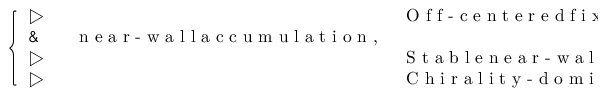<formula> <loc_0><loc_0><loc_500><loc_500>\begin{array} { r } { \left \{ \begin{array} { l l } { \triangleright \, } & { O f f - c e n t e r e d f i x e d p o i n t \colon } \\ { \& \quad n e a r - w a l l a c c u m u l a t i o n , } \\ { \triangleright \, } & { S t a b l e n e a r - w a l l f i x e d p o i n t \colon } \\ { \triangleright \, } & { C h i r a l i t y - d o \min a n t s w i m \min g \colon } \end{array} } \end{array}</formula> 